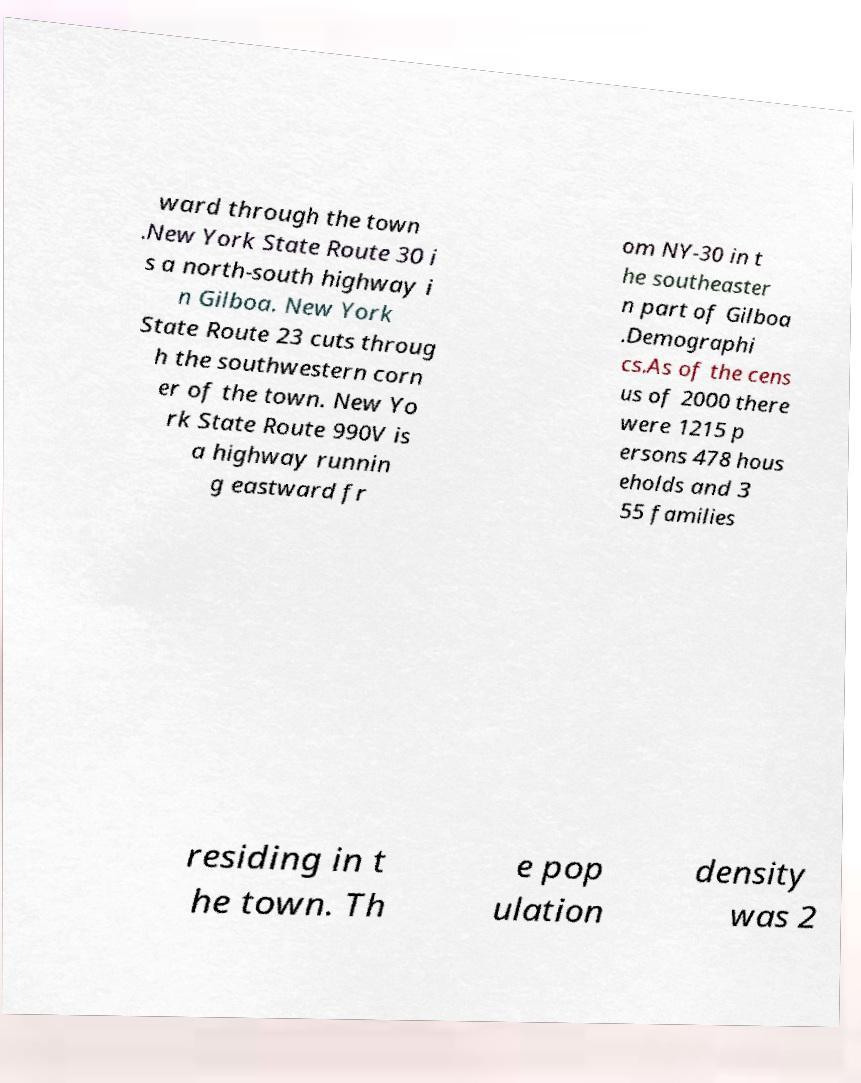Could you extract and type out the text from this image? ward through the town .New York State Route 30 i s a north-south highway i n Gilboa. New York State Route 23 cuts throug h the southwestern corn er of the town. New Yo rk State Route 990V is a highway runnin g eastward fr om NY-30 in t he southeaster n part of Gilboa .Demographi cs.As of the cens us of 2000 there were 1215 p ersons 478 hous eholds and 3 55 families residing in t he town. Th e pop ulation density was 2 